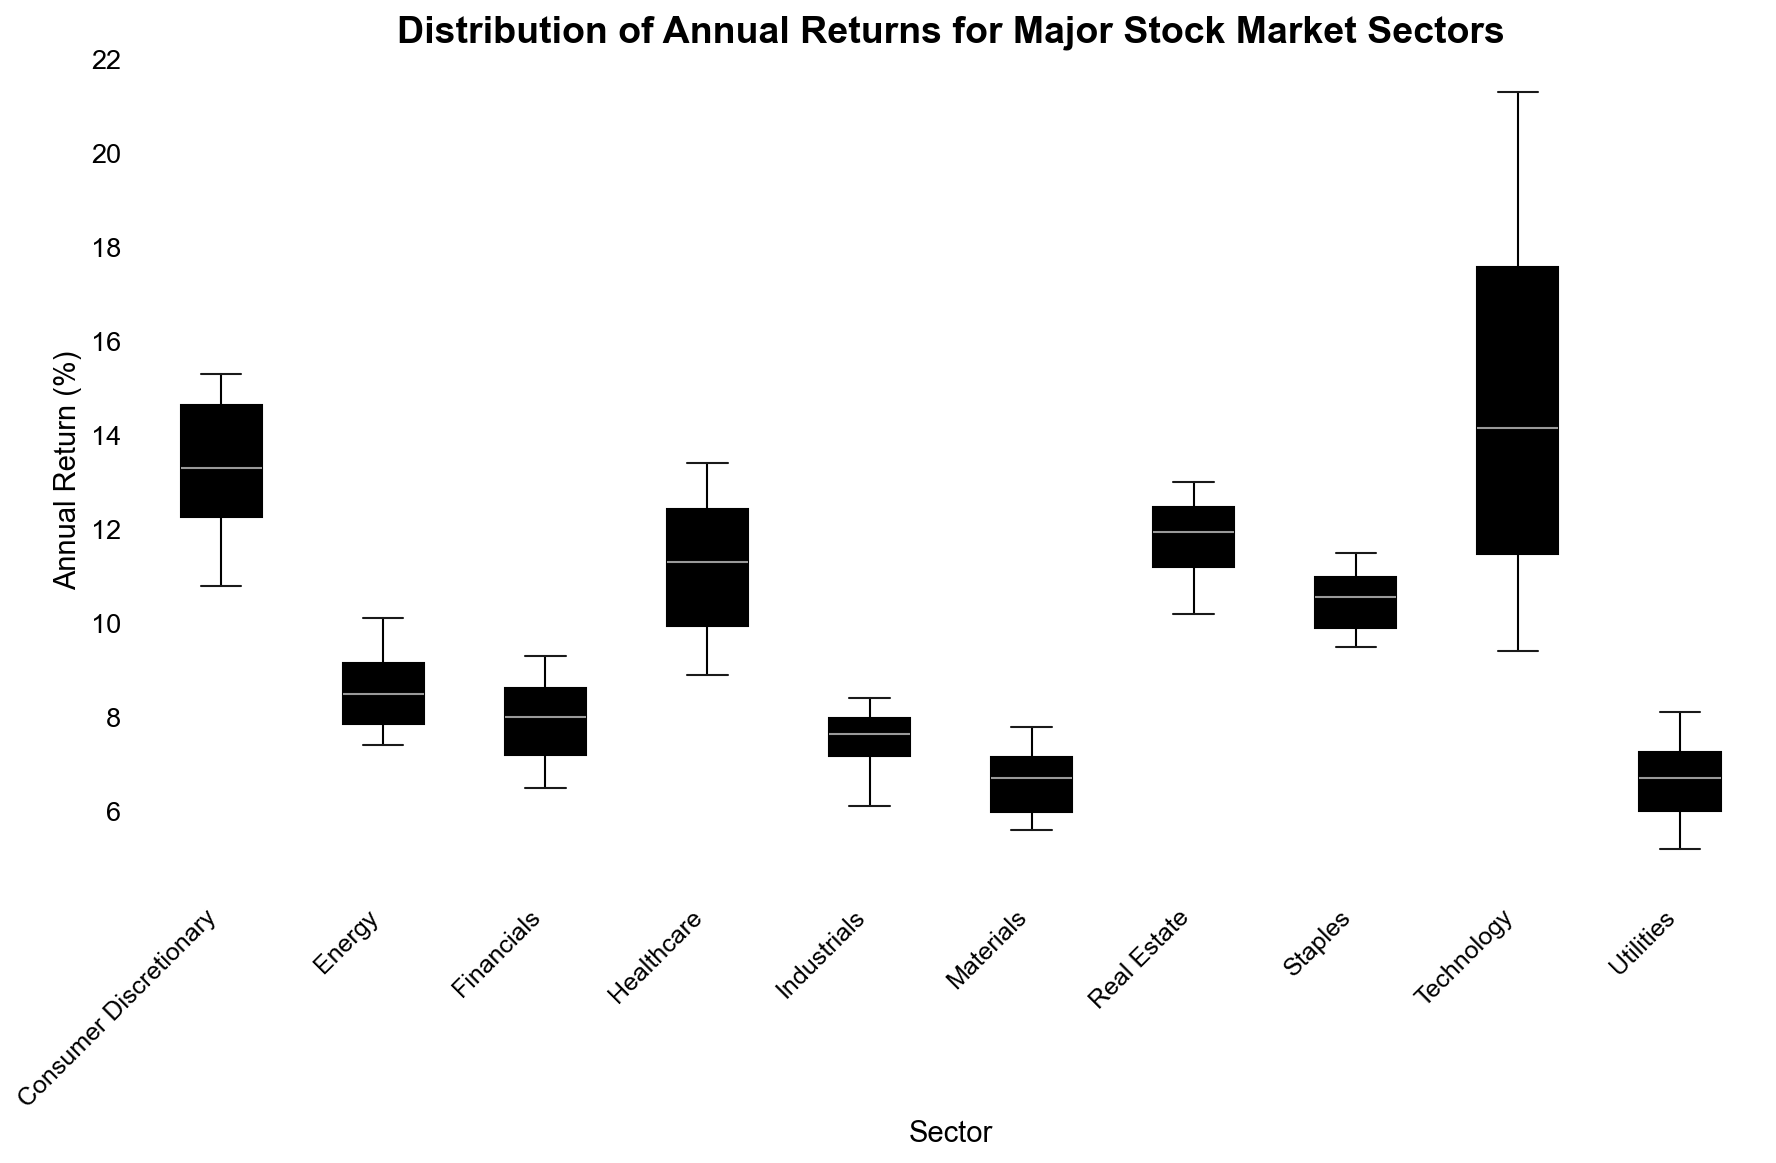What's the median annual return for the Technology sector? To find the median, list the annual returns of the Technology sector in ascending order: 9.4, 10.1, 11.2, 12.3, 13.5, 14.8, 15.1, 18.4, 20.5, 21.3. The middle value (or average of two middle values): (13.5 + 14.8) / 2 = 14.15
Answer: 14.15 Which sector has the highest median annual return? Compare the median values from the box plots of each sector. The sector whose median line is highest determines the answer.
Answer: Technology Which sector shows the largest range in annual returns? The range is the difference between the maximum and minimum values in the box plot's whiskers. Visually compare the lengths of whiskers for each sector.
Answer: Technology How do the median annual returns of Healthcare and Financials compare? Locate the median lines within the box plots for Healthcare and Financials sectors. Compare their positions. Healthcare's median line is higher than Financials'.
Answer: Healthcare > Financials Which sector's annual returns have the smallest interquartile range (IQR)? The IQR is the length of the box in the box plot. Identify the sector with the smallest box length.
Answer: Materials Is the upper quartile (Q3) of Utilities higher than the median of Industrials? Check the upper quartile line of Utilities' box plot and compare it horizontally to the median line of Industrials' box plot.
Answer: No What is the median annual return of the Consumer Discretionary sector? The median is the value at the center line of the box in the box plot for the Consumer Discretionary sector.
Answer: 13.35 Which sector has the widest spread between Q1 and maximum value? Determine the sector with the largest distance between the bottom of the box (Q1) and the top whisker.
Answer: Technology 